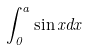Convert formula to latex. <formula><loc_0><loc_0><loc_500><loc_500>\int _ { 0 } ^ { a } \sin x d x</formula> 